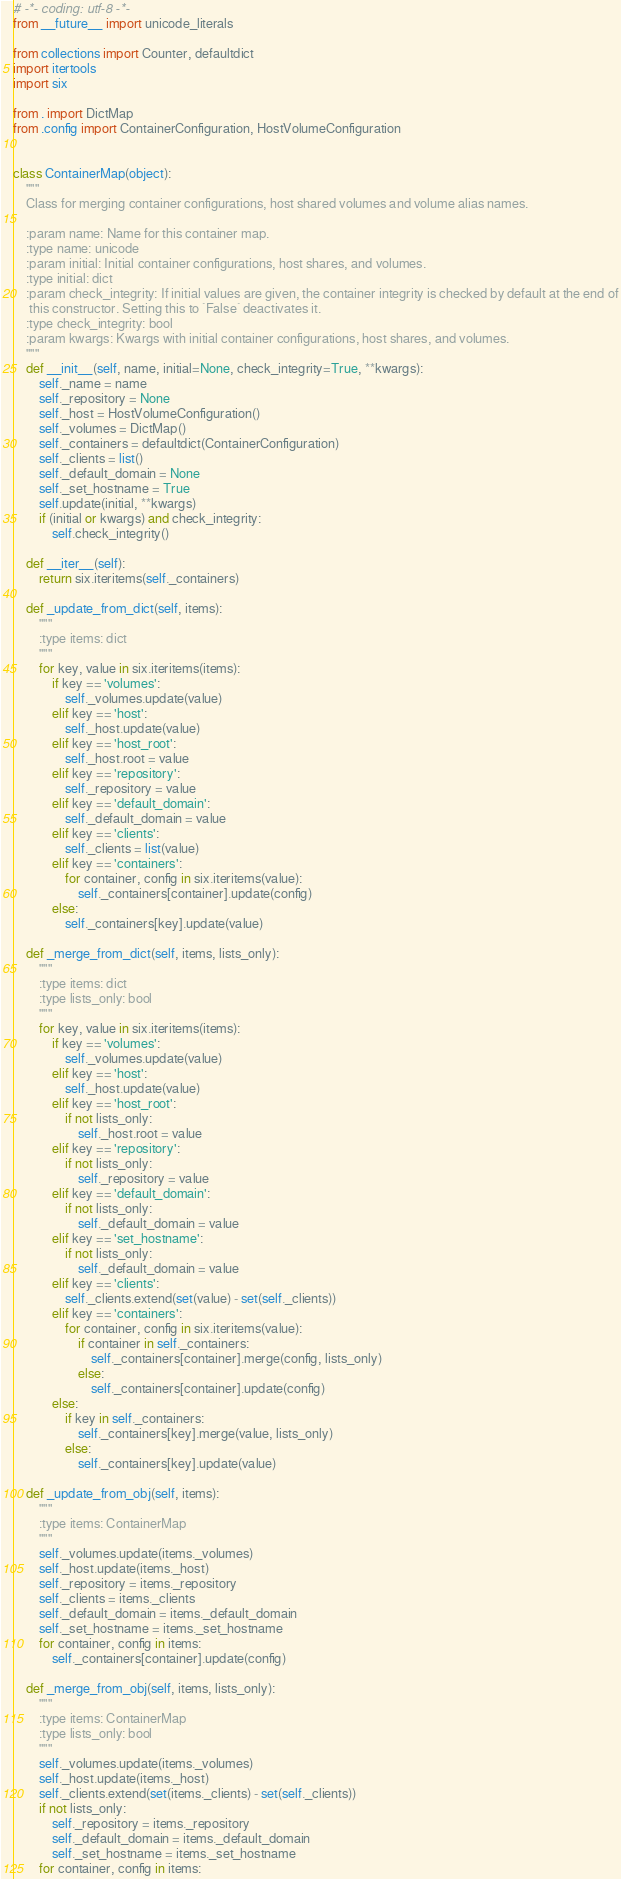Convert code to text. <code><loc_0><loc_0><loc_500><loc_500><_Python_># -*- coding: utf-8 -*-
from __future__ import unicode_literals

from collections import Counter, defaultdict
import itertools
import six

from . import DictMap
from .config import ContainerConfiguration, HostVolumeConfiguration


class ContainerMap(object):
    """
    Class for merging container configurations, host shared volumes and volume alias names.

    :param name: Name for this container map.
    :type name: unicode
    :param initial: Initial container configurations, host shares, and volumes.
    :type initial: dict
    :param check_integrity: If initial values are given, the container integrity is checked by default at the end of
     this constructor. Setting this to `False` deactivates it.
    :type check_integrity: bool
    :param kwargs: Kwargs with initial container configurations, host shares, and volumes.
    """
    def __init__(self, name, initial=None, check_integrity=True, **kwargs):
        self._name = name
        self._repository = None
        self._host = HostVolumeConfiguration()
        self._volumes = DictMap()
        self._containers = defaultdict(ContainerConfiguration)
        self._clients = list()
        self._default_domain = None
        self._set_hostname = True
        self.update(initial, **kwargs)
        if (initial or kwargs) and check_integrity:
            self.check_integrity()

    def __iter__(self):
        return six.iteritems(self._containers)

    def _update_from_dict(self, items):
        """
        :type items: dict
        """
        for key, value in six.iteritems(items):
            if key == 'volumes':
                self._volumes.update(value)
            elif key == 'host':
                self._host.update(value)
            elif key == 'host_root':
                self._host.root = value
            elif key == 'repository':
                self._repository = value
            elif key == 'default_domain':
                self._default_domain = value
            elif key == 'clients':
                self._clients = list(value)
            elif key == 'containers':
                for container, config in six.iteritems(value):
                    self._containers[container].update(config)
            else:
                self._containers[key].update(value)

    def _merge_from_dict(self, items, lists_only):
        """
        :type items: dict
        :type lists_only: bool
        """
        for key, value in six.iteritems(items):
            if key == 'volumes':
                self._volumes.update(value)
            elif key == 'host':
                self._host.update(value)
            elif key == 'host_root':
                if not lists_only:
                    self._host.root = value
            elif key == 'repository':
                if not lists_only:
                    self._repository = value
            elif key == 'default_domain':
                if not lists_only:
                    self._default_domain = value
            elif key == 'set_hostname':
                if not lists_only:
                    self._default_domain = value
            elif key == 'clients':
                self._clients.extend(set(value) - set(self._clients))
            elif key == 'containers':
                for container, config in six.iteritems(value):
                    if container in self._containers:
                        self._containers[container].merge(config, lists_only)
                    else:
                        self._containers[container].update(config)
            else:
                if key in self._containers:
                    self._containers[key].merge(value, lists_only)
                else:
                    self._containers[key].update(value)

    def _update_from_obj(self, items):
        """
        :type items: ContainerMap
        """
        self._volumes.update(items._volumes)
        self._host.update(items._host)
        self._repository = items._repository
        self._clients = items._clients
        self._default_domain = items._default_domain
        self._set_hostname = items._set_hostname
        for container, config in items:
            self._containers[container].update(config)

    def _merge_from_obj(self, items, lists_only):
        """
        :type items: ContainerMap
        :type lists_only: bool
        """
        self._volumes.update(items._volumes)
        self._host.update(items._host)
        self._clients.extend(set(items._clients) - set(self._clients))
        if not lists_only:
            self._repository = items._repository
            self._default_domain = items._default_domain
            self._set_hostname = items._set_hostname
        for container, config in items:</code> 